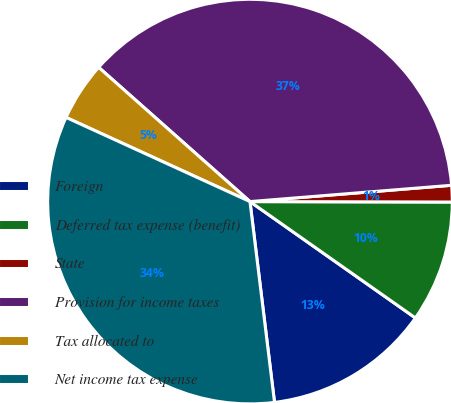Convert chart. <chart><loc_0><loc_0><loc_500><loc_500><pie_chart><fcel>Foreign<fcel>Deferred tax expense (benefit)<fcel>State<fcel>Provision for income taxes<fcel>Tax allocated to<fcel>Net income tax expense<nl><fcel>13.31%<fcel>9.72%<fcel>1.32%<fcel>37.17%<fcel>4.72%<fcel>33.77%<nl></chart> 